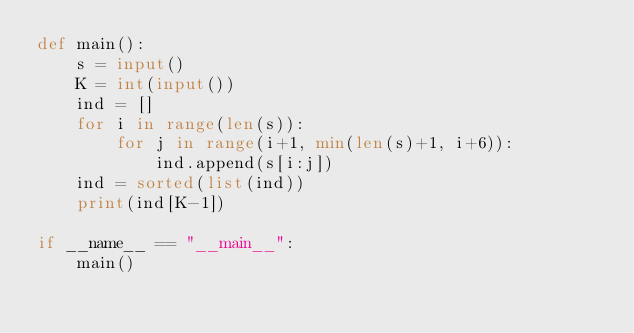<code> <loc_0><loc_0><loc_500><loc_500><_Python_>def main():
    s = input()
    K = int(input())
    ind = []
    for i in range(len(s)):
        for j in range(i+1, min(len(s)+1, i+6)):
            ind.append(s[i:j])
    ind = sorted(list(ind))
    print(ind[K-1])

if __name__ == "__main__":
    main()</code> 